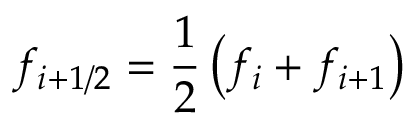Convert formula to latex. <formula><loc_0><loc_0><loc_500><loc_500>f _ { i + 1 / 2 } = \frac { 1 } { 2 } \left ( f _ { i } + f _ { i + 1 } \right )</formula> 